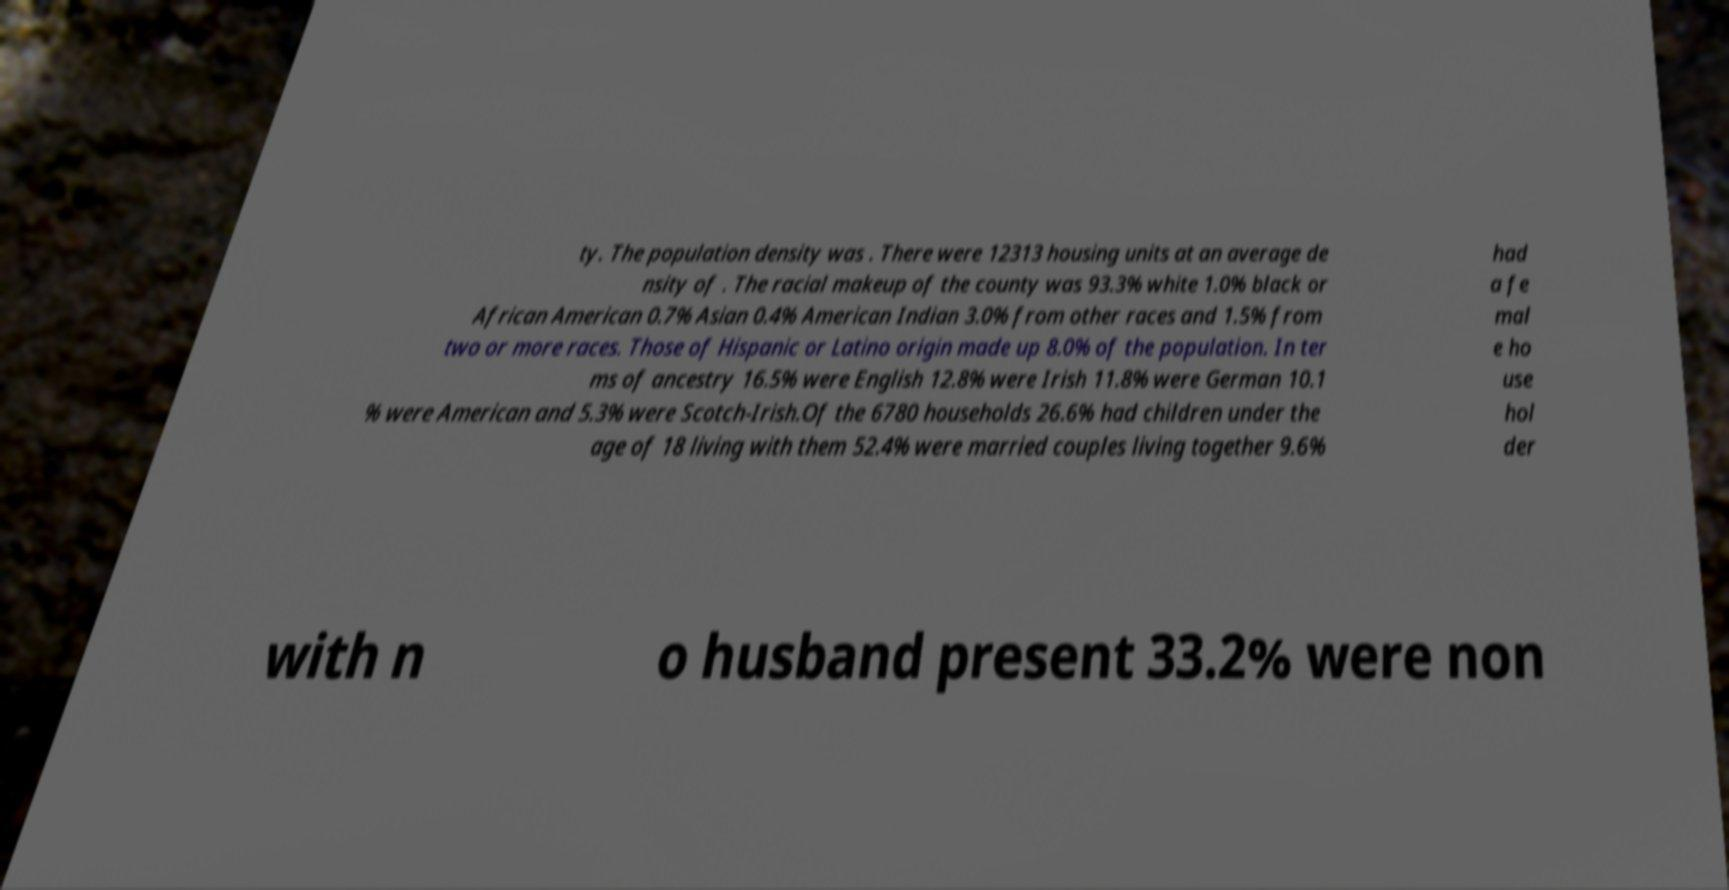I need the written content from this picture converted into text. Can you do that? ty. The population density was . There were 12313 housing units at an average de nsity of . The racial makeup of the county was 93.3% white 1.0% black or African American 0.7% Asian 0.4% American Indian 3.0% from other races and 1.5% from two or more races. Those of Hispanic or Latino origin made up 8.0% of the population. In ter ms of ancestry 16.5% were English 12.8% were Irish 11.8% were German 10.1 % were American and 5.3% were Scotch-Irish.Of the 6780 households 26.6% had children under the age of 18 living with them 52.4% were married couples living together 9.6% had a fe mal e ho use hol der with n o husband present 33.2% were non 